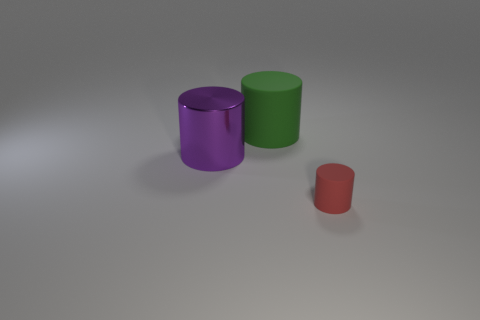Is the number of tiny red cylinders greater than the number of small blue rubber cylinders?
Ensure brevity in your answer.  Yes. What number of other green cylinders have the same size as the green matte cylinder?
Make the answer very short. 0. What number of objects are things that are behind the red thing or purple shiny cylinders?
Provide a short and direct response. 2. Are there fewer red cylinders than large cubes?
Provide a short and direct response. No. What is the shape of the green thing that is made of the same material as the tiny cylinder?
Provide a short and direct response. Cylinder. There is a large green cylinder; are there any small red things right of it?
Ensure brevity in your answer.  Yes. Are there fewer big green cylinders left of the red cylinder than large green metal things?
Your answer should be very brief. No. What is the purple cylinder made of?
Keep it short and to the point. Metal. The tiny object is what color?
Your answer should be compact. Red. There is a thing that is on the right side of the metallic cylinder and on the left side of the small cylinder; what is its color?
Your answer should be compact. Green. 